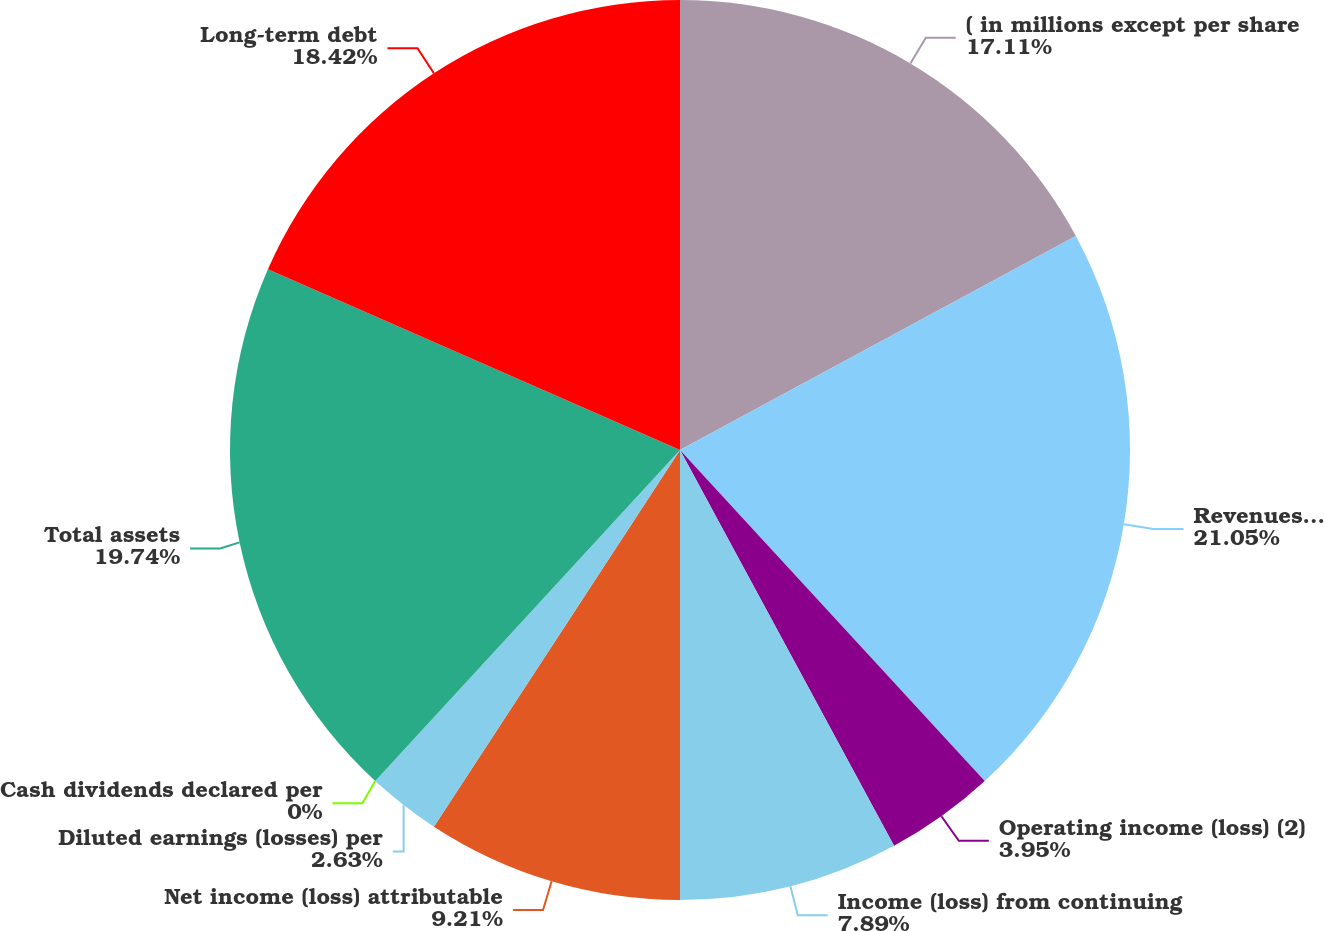Convert chart to OTSL. <chart><loc_0><loc_0><loc_500><loc_500><pie_chart><fcel>( in millions except per share<fcel>Revenues (2)<fcel>Operating income (loss) (2)<fcel>Income (loss) from continuing<fcel>Net income (loss) attributable<fcel>Diluted earnings (losses) per<fcel>Cash dividends declared per<fcel>Total assets<fcel>Long-term debt<nl><fcel>17.11%<fcel>21.05%<fcel>3.95%<fcel>7.89%<fcel>9.21%<fcel>2.63%<fcel>0.0%<fcel>19.74%<fcel>18.42%<nl></chart> 